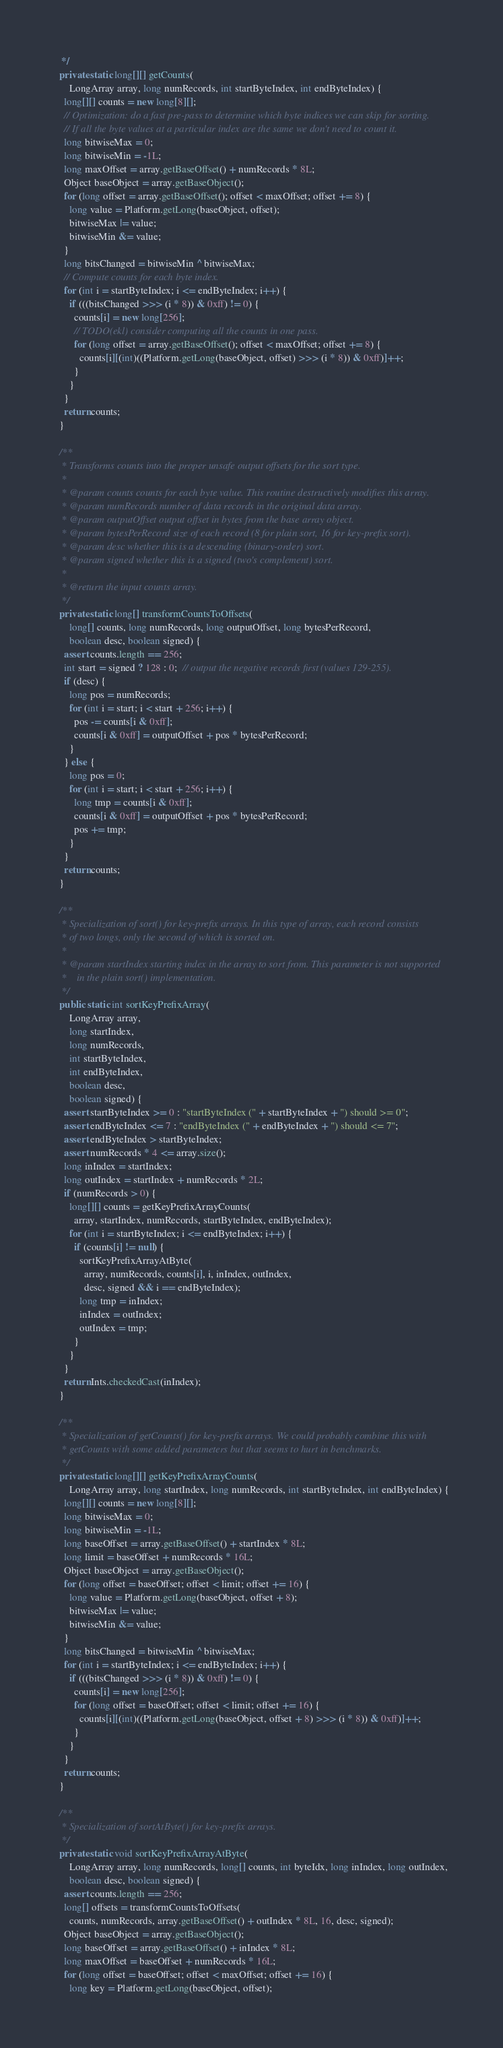Convert code to text. <code><loc_0><loc_0><loc_500><loc_500><_Java_>   */
  private static long[][] getCounts(
      LongArray array, long numRecords, int startByteIndex, int endByteIndex) {
    long[][] counts = new long[8][];
    // Optimization: do a fast pre-pass to determine which byte indices we can skip for sorting.
    // If all the byte values at a particular index are the same we don't need to count it.
    long bitwiseMax = 0;
    long bitwiseMin = -1L;
    long maxOffset = array.getBaseOffset() + numRecords * 8L;
    Object baseObject = array.getBaseObject();
    for (long offset = array.getBaseOffset(); offset < maxOffset; offset += 8) {
      long value = Platform.getLong(baseObject, offset);
      bitwiseMax |= value;
      bitwiseMin &= value;
    }
    long bitsChanged = bitwiseMin ^ bitwiseMax;
    // Compute counts for each byte index.
    for (int i = startByteIndex; i <= endByteIndex; i++) {
      if (((bitsChanged >>> (i * 8)) & 0xff) != 0) {
        counts[i] = new long[256];
        // TODO(ekl) consider computing all the counts in one pass.
        for (long offset = array.getBaseOffset(); offset < maxOffset; offset += 8) {
          counts[i][(int)((Platform.getLong(baseObject, offset) >>> (i * 8)) & 0xff)]++;
        }
      }
    }
    return counts;
  }

  /**
   * Transforms counts into the proper unsafe output offsets for the sort type.
   *
   * @param counts counts for each byte value. This routine destructively modifies this array.
   * @param numRecords number of data records in the original data array.
   * @param outputOffset output offset in bytes from the base array object.
   * @param bytesPerRecord size of each record (8 for plain sort, 16 for key-prefix sort).
   * @param desc whether this is a descending (binary-order) sort.
   * @param signed whether this is a signed (two's complement) sort.
   *
   * @return the input counts array.
   */
  private static long[] transformCountsToOffsets(
      long[] counts, long numRecords, long outputOffset, long bytesPerRecord,
      boolean desc, boolean signed) {
    assert counts.length == 256;
    int start = signed ? 128 : 0;  // output the negative records first (values 129-255).
    if (desc) {
      long pos = numRecords;
      for (int i = start; i < start + 256; i++) {
        pos -= counts[i & 0xff];
        counts[i & 0xff] = outputOffset + pos * bytesPerRecord;
      }
    } else {
      long pos = 0;
      for (int i = start; i < start + 256; i++) {
        long tmp = counts[i & 0xff];
        counts[i & 0xff] = outputOffset + pos * bytesPerRecord;
        pos += tmp;
      }
    }
    return counts;
  }

  /**
   * Specialization of sort() for key-prefix arrays. In this type of array, each record consists
   * of two longs, only the second of which is sorted on.
   *
   * @param startIndex starting index in the array to sort from. This parameter is not supported
   *    in the plain sort() implementation.
   */
  public static int sortKeyPrefixArray(
      LongArray array,
      long startIndex,
      long numRecords,
      int startByteIndex,
      int endByteIndex,
      boolean desc,
      boolean signed) {
    assert startByteIndex >= 0 : "startByteIndex (" + startByteIndex + ") should >= 0";
    assert endByteIndex <= 7 : "endByteIndex (" + endByteIndex + ") should <= 7";
    assert endByteIndex > startByteIndex;
    assert numRecords * 4 <= array.size();
    long inIndex = startIndex;
    long outIndex = startIndex + numRecords * 2L;
    if (numRecords > 0) {
      long[][] counts = getKeyPrefixArrayCounts(
        array, startIndex, numRecords, startByteIndex, endByteIndex);
      for (int i = startByteIndex; i <= endByteIndex; i++) {
        if (counts[i] != null) {
          sortKeyPrefixArrayAtByte(
            array, numRecords, counts[i], i, inIndex, outIndex,
            desc, signed && i == endByteIndex);
          long tmp = inIndex;
          inIndex = outIndex;
          outIndex = tmp;
        }
      }
    }
    return Ints.checkedCast(inIndex);
  }

  /**
   * Specialization of getCounts() for key-prefix arrays. We could probably combine this with
   * getCounts with some added parameters but that seems to hurt in benchmarks.
   */
  private static long[][] getKeyPrefixArrayCounts(
      LongArray array, long startIndex, long numRecords, int startByteIndex, int endByteIndex) {
    long[][] counts = new long[8][];
    long bitwiseMax = 0;
    long bitwiseMin = -1L;
    long baseOffset = array.getBaseOffset() + startIndex * 8L;
    long limit = baseOffset + numRecords * 16L;
    Object baseObject = array.getBaseObject();
    for (long offset = baseOffset; offset < limit; offset += 16) {
      long value = Platform.getLong(baseObject, offset + 8);
      bitwiseMax |= value;
      bitwiseMin &= value;
    }
    long bitsChanged = bitwiseMin ^ bitwiseMax;
    for (int i = startByteIndex; i <= endByteIndex; i++) {
      if (((bitsChanged >>> (i * 8)) & 0xff) != 0) {
        counts[i] = new long[256];
        for (long offset = baseOffset; offset < limit; offset += 16) {
          counts[i][(int)((Platform.getLong(baseObject, offset + 8) >>> (i * 8)) & 0xff)]++;
        }
      }
    }
    return counts;
  }

  /**
   * Specialization of sortAtByte() for key-prefix arrays.
   */
  private static void sortKeyPrefixArrayAtByte(
      LongArray array, long numRecords, long[] counts, int byteIdx, long inIndex, long outIndex,
      boolean desc, boolean signed) {
    assert counts.length == 256;
    long[] offsets = transformCountsToOffsets(
      counts, numRecords, array.getBaseOffset() + outIndex * 8L, 16, desc, signed);
    Object baseObject = array.getBaseObject();
    long baseOffset = array.getBaseOffset() + inIndex * 8L;
    long maxOffset = baseOffset + numRecords * 16L;
    for (long offset = baseOffset; offset < maxOffset; offset += 16) {
      long key = Platform.getLong(baseObject, offset);</code> 